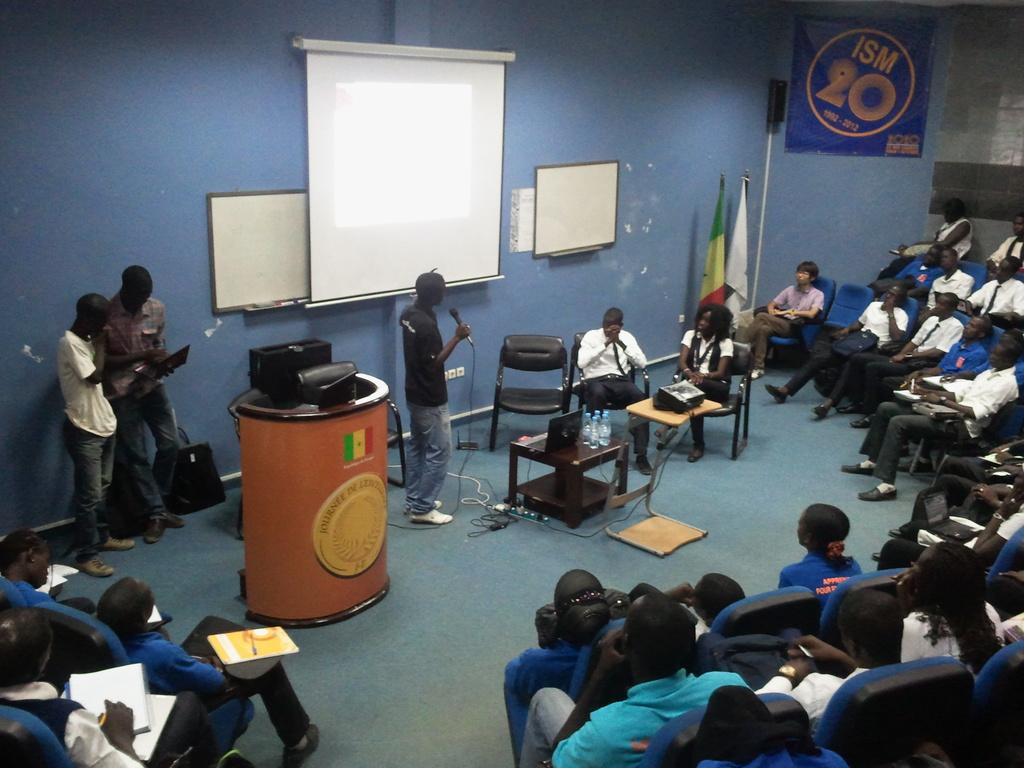What is the person in the image wearing? The person in the image is wearing a black shirt. What is the person doing in the image? The person is sitting in front of a microphone. What can be seen behind the person? There is a projector behind the person. Who is present in the image besides the person with the microphone? There is a group of people sitting in front of the person. What type of fruit is being drained by the governor in the image? There is no fruit or governor present in the image. 